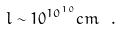Convert formula to latex. <formula><loc_0><loc_0><loc_500><loc_500>l \sim 1 0 ^ { 1 0 ^ { 1 0 } } c m \ .</formula> 